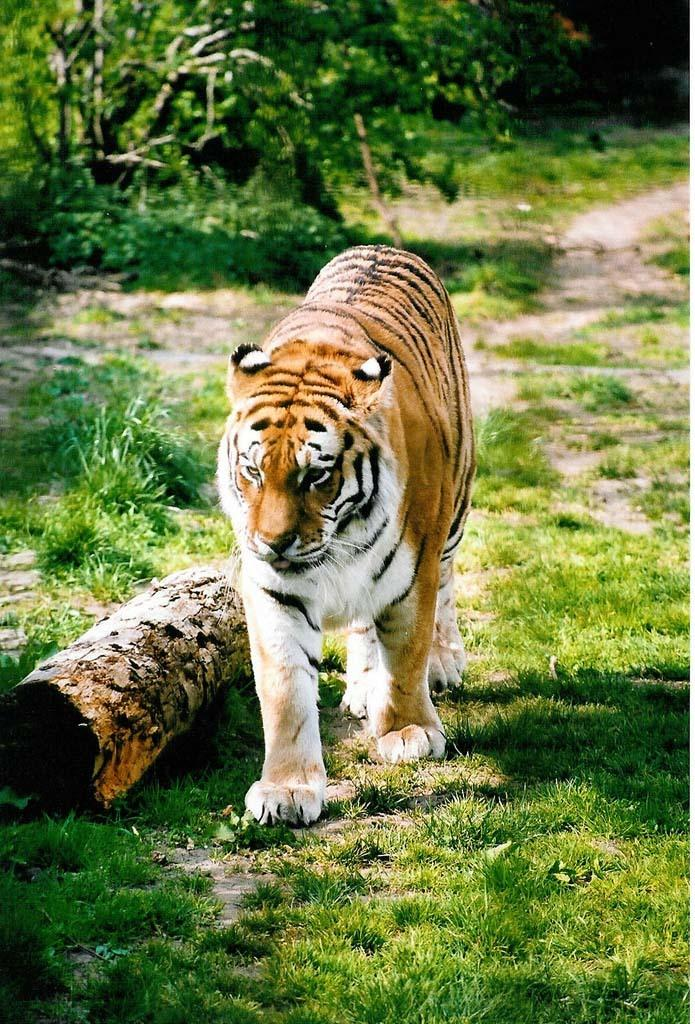What animal is in the image? There is a tiger in the image. What is the tiger doing in the image? The tiger is walking on the grassland. What can be seen beside the tiger in the image? There is a tree bark beside the tiger. What type of dinner is being served in the image? There is no dinner or any indication of food in the image; it features a tiger walking on the grassland. What action is the flag performing in the image? There is no flag present in the image. 